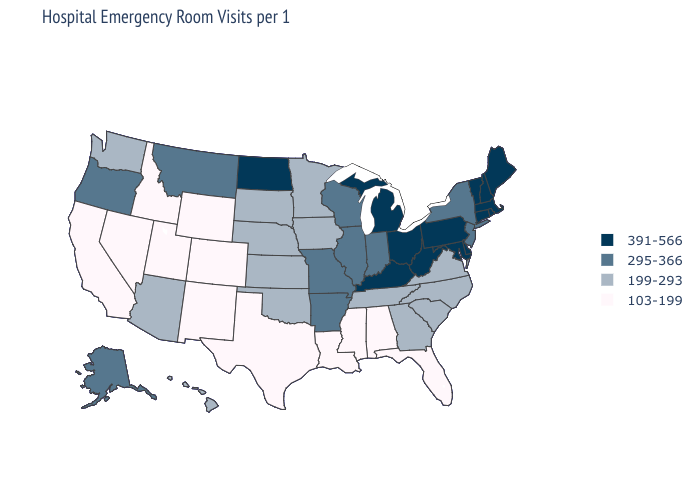What is the value of Oklahoma?
Write a very short answer. 199-293. Which states hav the highest value in the South?
Short answer required. Delaware, Kentucky, Maryland, West Virginia. What is the value of Florida?
Short answer required. 103-199. Which states have the lowest value in the Northeast?
Be succinct. New Jersey, New York. Among the states that border Maine , which have the highest value?
Give a very brief answer. New Hampshire. Name the states that have a value in the range 391-566?
Keep it brief. Connecticut, Delaware, Kentucky, Maine, Maryland, Massachusetts, Michigan, New Hampshire, North Dakota, Ohio, Pennsylvania, Rhode Island, Vermont, West Virginia. Name the states that have a value in the range 199-293?
Write a very short answer. Arizona, Georgia, Hawaii, Iowa, Kansas, Minnesota, Nebraska, North Carolina, Oklahoma, South Carolina, South Dakota, Tennessee, Virginia, Washington. Name the states that have a value in the range 199-293?
Write a very short answer. Arizona, Georgia, Hawaii, Iowa, Kansas, Minnesota, Nebraska, North Carolina, Oklahoma, South Carolina, South Dakota, Tennessee, Virginia, Washington. Name the states that have a value in the range 391-566?
Give a very brief answer. Connecticut, Delaware, Kentucky, Maine, Maryland, Massachusetts, Michigan, New Hampshire, North Dakota, Ohio, Pennsylvania, Rhode Island, Vermont, West Virginia. Among the states that border Utah , does Nevada have the lowest value?
Quick response, please. Yes. Among the states that border Arkansas , does Missouri have the highest value?
Concise answer only. Yes. What is the value of Connecticut?
Quick response, please. 391-566. Which states hav the highest value in the West?
Short answer required. Alaska, Montana, Oregon. Among the states that border California , does Oregon have the highest value?
Write a very short answer. Yes. Does Minnesota have a lower value than Maine?
Concise answer only. Yes. 